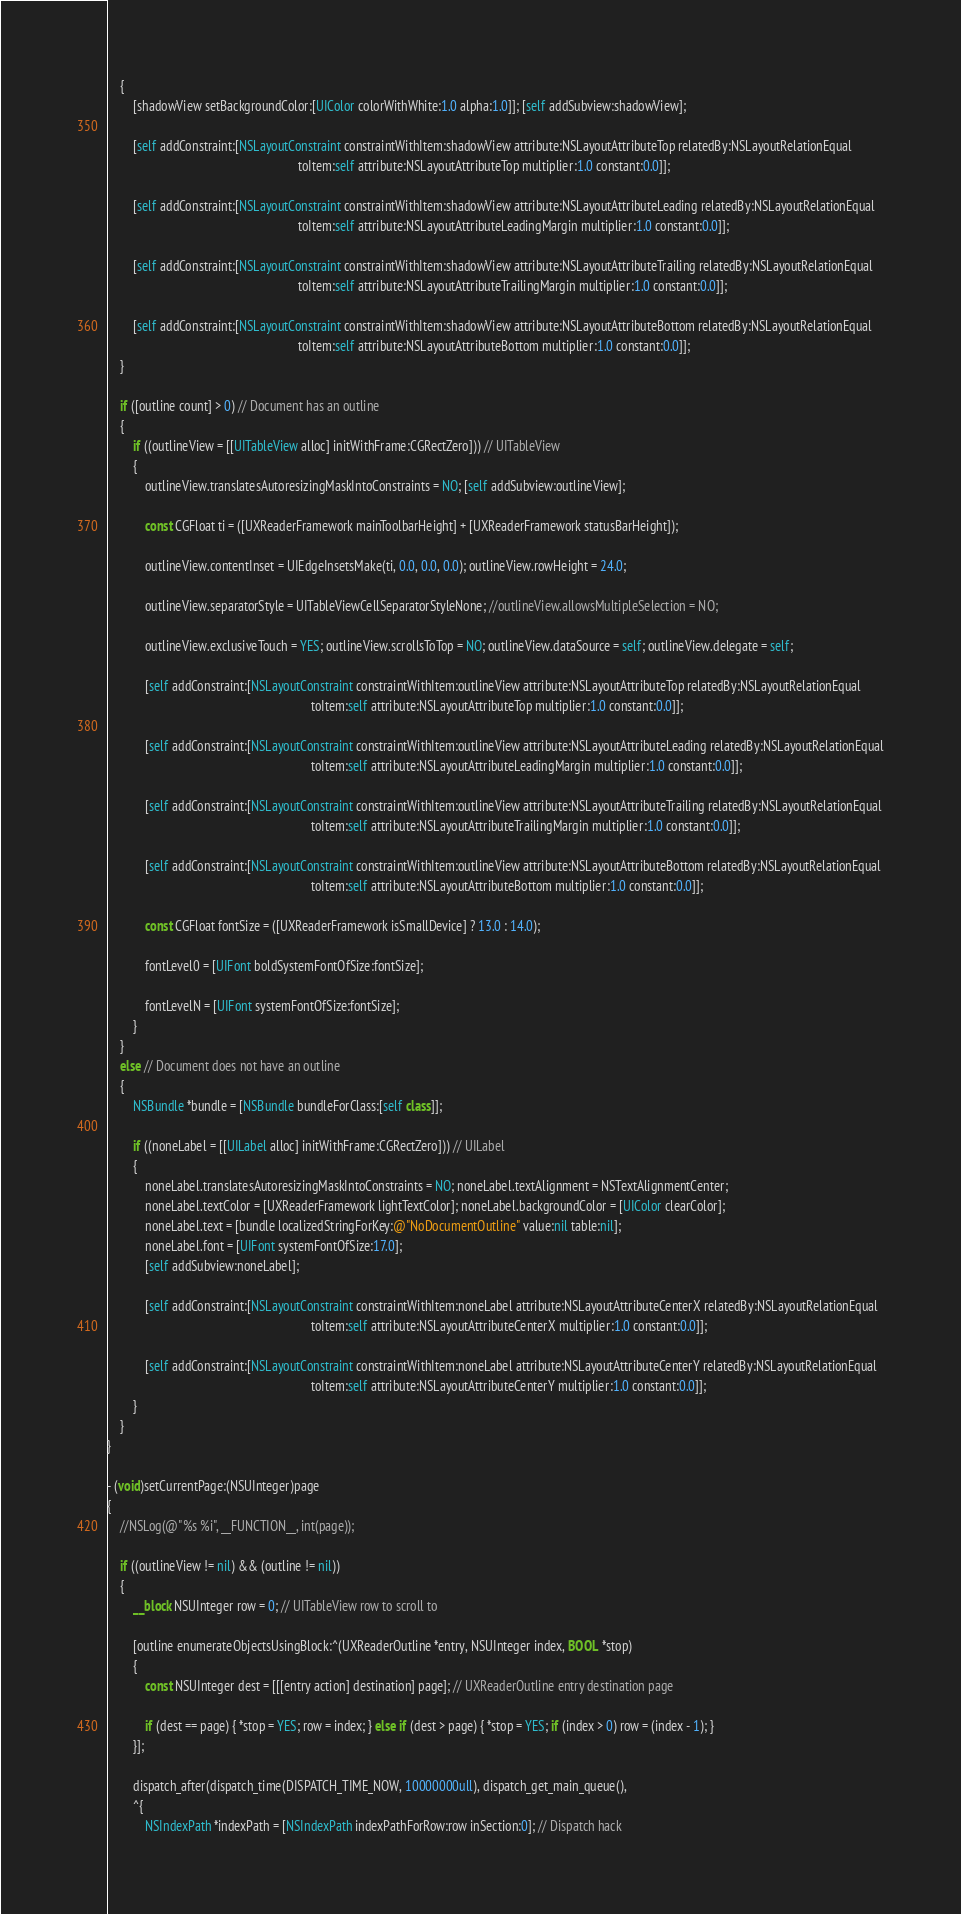Convert code to text. <code><loc_0><loc_0><loc_500><loc_500><_ObjectiveC_>	{
		[shadowView setBackgroundColor:[UIColor colorWithWhite:1.0 alpha:1.0]]; [self addSubview:shadowView];

		[self addConstraint:[NSLayoutConstraint constraintWithItem:shadowView attribute:NSLayoutAttributeTop relatedBy:NSLayoutRelationEqual
															toItem:self attribute:NSLayoutAttributeTop multiplier:1.0 constant:0.0]];

		[self addConstraint:[NSLayoutConstraint constraintWithItem:shadowView attribute:NSLayoutAttributeLeading relatedBy:NSLayoutRelationEqual
															toItem:self attribute:NSLayoutAttributeLeadingMargin multiplier:1.0 constant:0.0]];

		[self addConstraint:[NSLayoutConstraint constraintWithItem:shadowView attribute:NSLayoutAttributeTrailing relatedBy:NSLayoutRelationEqual
															toItem:self attribute:NSLayoutAttributeTrailingMargin multiplier:1.0 constant:0.0]];

		[self addConstraint:[NSLayoutConstraint constraintWithItem:shadowView attribute:NSLayoutAttributeBottom relatedBy:NSLayoutRelationEqual
															toItem:self attribute:NSLayoutAttributeBottom multiplier:1.0 constant:0.0]];
	}

	if ([outline count] > 0) // Document has an outline
	{
		if ((outlineView = [[UITableView alloc] initWithFrame:CGRectZero])) // UITableView
		{
			outlineView.translatesAutoresizingMaskIntoConstraints = NO; [self addSubview:outlineView];

			const CGFloat ti = ([UXReaderFramework mainToolbarHeight] + [UXReaderFramework statusBarHeight]);

			outlineView.contentInset = UIEdgeInsetsMake(ti, 0.0, 0.0, 0.0); outlineView.rowHeight = 24.0;

			outlineView.separatorStyle = UITableViewCellSeparatorStyleNone; //outlineView.allowsMultipleSelection = NO;

			outlineView.exclusiveTouch = YES; outlineView.scrollsToTop = NO; outlineView.dataSource = self; outlineView.delegate = self;

			[self addConstraint:[NSLayoutConstraint constraintWithItem:outlineView attribute:NSLayoutAttributeTop relatedBy:NSLayoutRelationEqual
																toItem:self attribute:NSLayoutAttributeTop multiplier:1.0 constant:0.0]];

			[self addConstraint:[NSLayoutConstraint constraintWithItem:outlineView attribute:NSLayoutAttributeLeading relatedBy:NSLayoutRelationEqual
																toItem:self attribute:NSLayoutAttributeLeadingMargin multiplier:1.0 constant:0.0]];

			[self addConstraint:[NSLayoutConstraint constraintWithItem:outlineView attribute:NSLayoutAttributeTrailing relatedBy:NSLayoutRelationEqual
																toItem:self attribute:NSLayoutAttributeTrailingMargin multiplier:1.0 constant:0.0]];

			[self addConstraint:[NSLayoutConstraint constraintWithItem:outlineView attribute:NSLayoutAttributeBottom relatedBy:NSLayoutRelationEqual
																toItem:self attribute:NSLayoutAttributeBottom multiplier:1.0 constant:0.0]];

			const CGFloat fontSize = ([UXReaderFramework isSmallDevice] ? 13.0 : 14.0);

			fontLevel0 = [UIFont boldSystemFontOfSize:fontSize];

			fontLevelN = [UIFont systemFontOfSize:fontSize];
		}
	}
	else // Document does not have an outline
	{
		NSBundle *bundle = [NSBundle bundleForClass:[self class]];

		if ((noneLabel = [[UILabel alloc] initWithFrame:CGRectZero])) // UILabel
		{
			noneLabel.translatesAutoresizingMaskIntoConstraints = NO; noneLabel.textAlignment = NSTextAlignmentCenter;
			noneLabel.textColor = [UXReaderFramework lightTextColor]; noneLabel.backgroundColor = [UIColor clearColor];
			noneLabel.text = [bundle localizedStringForKey:@"NoDocumentOutline" value:nil table:nil];
			noneLabel.font = [UIFont systemFontOfSize:17.0];
			[self addSubview:noneLabel];

			[self addConstraint:[NSLayoutConstraint constraintWithItem:noneLabel attribute:NSLayoutAttributeCenterX relatedBy:NSLayoutRelationEqual
																toItem:self attribute:NSLayoutAttributeCenterX multiplier:1.0 constant:0.0]];

			[self addConstraint:[NSLayoutConstraint constraintWithItem:noneLabel attribute:NSLayoutAttributeCenterY relatedBy:NSLayoutRelationEqual
																toItem:self attribute:NSLayoutAttributeCenterY multiplier:1.0 constant:0.0]];
		}
	}
}

- (void)setCurrentPage:(NSUInteger)page
{
	//NSLog(@"%s %i", __FUNCTION__, int(page));

	if ((outlineView != nil) && (outline != nil))
	{
		__block NSUInteger row = 0; // UITableView row to scroll to

		[outline enumerateObjectsUsingBlock:^(UXReaderOutline *entry, NSUInteger index, BOOL *stop)
		{
			const NSUInteger dest = [[[entry action] destination] page]; // UXReaderOutline entry destination page

			if (dest == page) { *stop = YES; row = index; } else if (dest > page) { *stop = YES; if (index > 0) row = (index - 1); }
		}];

		dispatch_after(dispatch_time(DISPATCH_TIME_NOW, 10000000ull), dispatch_get_main_queue(),
		^{
			NSIndexPath *indexPath = [NSIndexPath indexPathForRow:row inSection:0]; // Dispatch hack
</code> 